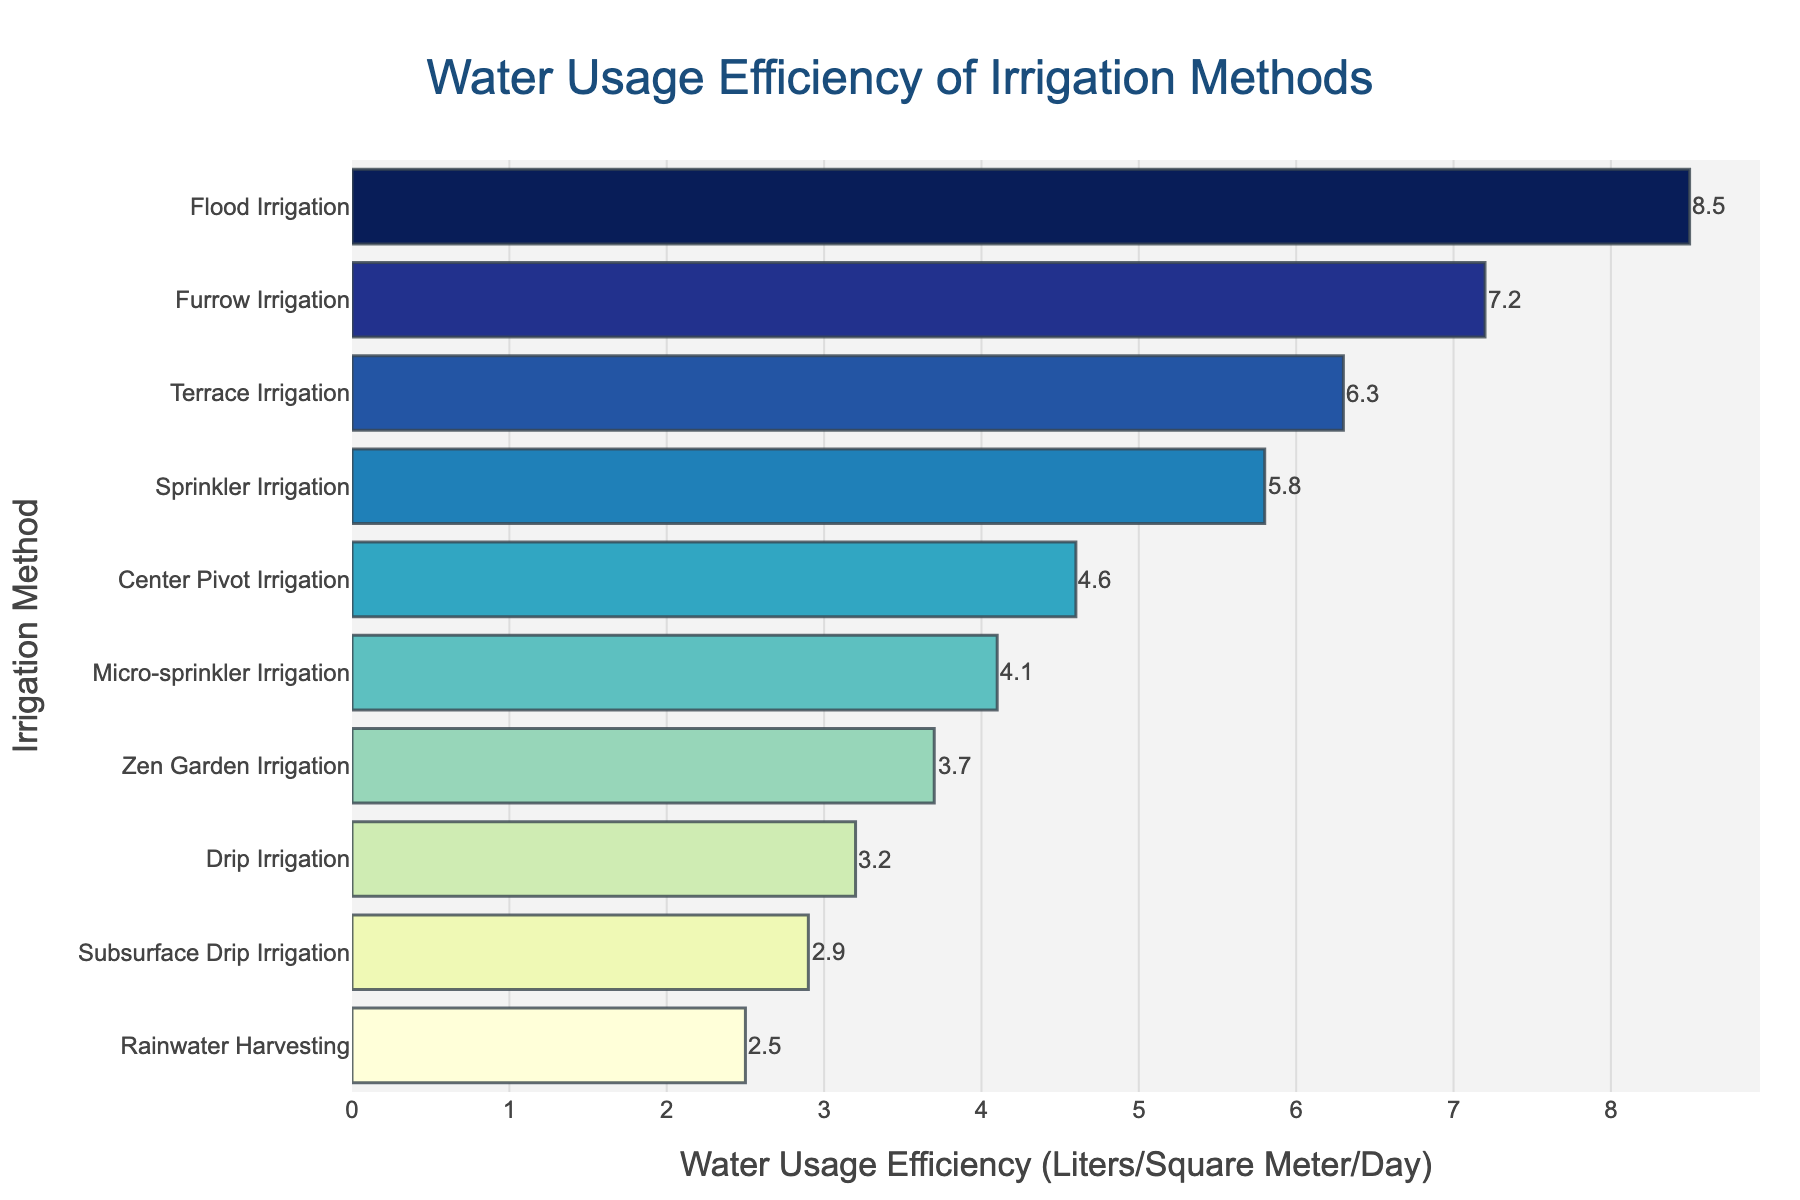How many irrigation methods have a water usage efficiency less than 5 liters per square meter per day? Count the number of bars representing irrigation methods with values less than 5 on the x-axis. Drip Irrigation, Subsurface Drip Irrigation, Rainwater Harvesting, Zen Garden Irrigation, and Center Pivot Irrigation each have efficiencies less than 5 liters per square meter per day.
Answer: 5 Which irrigation method has the highest water usage efficiency? Identify the bar that extends furthest to the right on the x-axis, indicating the highest water usage efficiency. The Flood Irrigation bar is the longest, representing the highest water usage efficiency.
Answer: Flood Irrigation What is the difference in water usage efficiency between Sprinkler Irrigation and Drip Irrigation? Identify the water usage efficiencies for Sprinkler Irrigation (5.8) and Drip Irrigation (3.2) and subtract the smaller value from the larger value. The difference is 5.8 - 3.2.
Answer: 2.6 Which two irrigation methods have the closest water usage efficiency values? Examine the bar lengths and identify two bars that are closest to each other. The Drip Irrigation (3.2) and Zen Garden Irrigation (3.7) values are closest, with a difference of 0.5.
Answer: Drip Irrigation and Zen Garden Irrigation What is the average water usage efficiency for the three most efficient methods? Identify the three methods with the smallest values (Rainwater Harvesting, Subsurface Drip Irrigation, and Drip Irrigation). Add their efficiencies (2.5 + 2.9 + 3.2) and divide by 3.
Answer: 2.87 Which irrigation method is more efficient, Furrow Irrigation or Terrace Irrigation? Compare the water usage efficiency values of Furrow Irrigation (7.2) and Terrace Irrigation (6.3). Furrow Irrigation has a higher value, hence is less efficient.
Answer: Terrace Irrigation What is the total water usage efficiency of Micro-sprinkler Irrigation and Center Pivot Irrigation combined? Identify and add the values for Micro-sprinkler Irrigation (4.1) and Center Pivot Irrigation (4.6). The total is 4.1 + 4.6.
Answer: 8.7 On average, how much more efficient is Rainwater Harvesting compared to Flood Irrigation? Subtract the efficiency value of Rainwater Harvesting (2.5) from Flood Irrigation (8.5) to find the absolute difference. Calculate the average difference by dividing it by 2. (8.5 - 2.5) / 2.
Answer: 3.0 How does micro-sprinkler irrigation compare in efficiency to center pivot irrigation? Compare their water usage efficiency values. Micro-sprinkler Irrigation is 4.1 while Center Pivot Irrigation is 4.6; hence, Micro-sprinkler is more efficient.
Answer: Micro-sprinkler is more efficient What is the median water usage efficiency value of all irrigation methods? Arrange all efficiency values in ascending order: (2.5, 2.9, 3.2, 3.7, 4.1, 4.6, 5.8, 6.3, 7.2, 8.5). The middle value in this ordered list is 4.35 (average of 4.1 and 4.6).
Answer: 4.35 